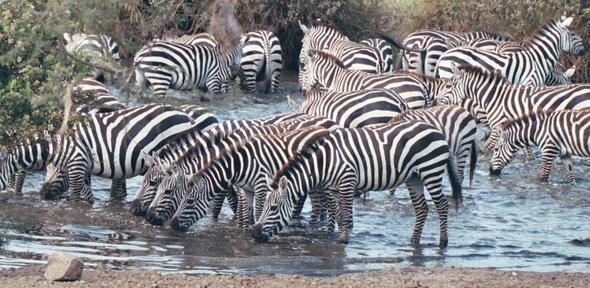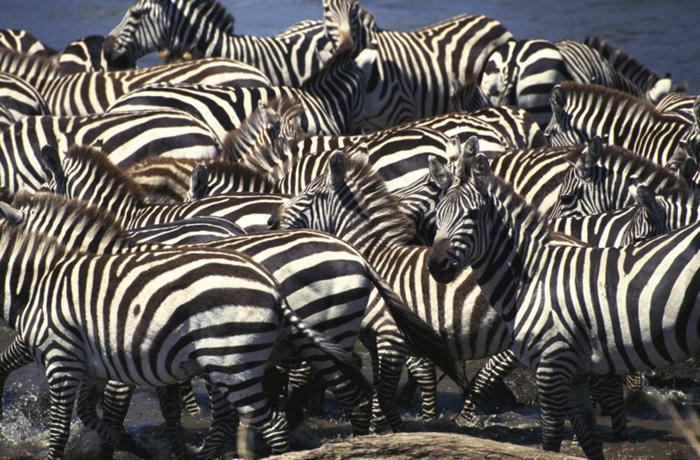The first image is the image on the left, the second image is the image on the right. Analyze the images presented: Is the assertion "Some of the zebras are standing in water in one of the images." valid? Answer yes or no. Yes. The first image is the image on the left, the second image is the image on the right. Evaluate the accuracy of this statement regarding the images: "The left image includes a row of leftward-facing zebras standing in water and bending their necks to drink.". Is it true? Answer yes or no. Yes. 